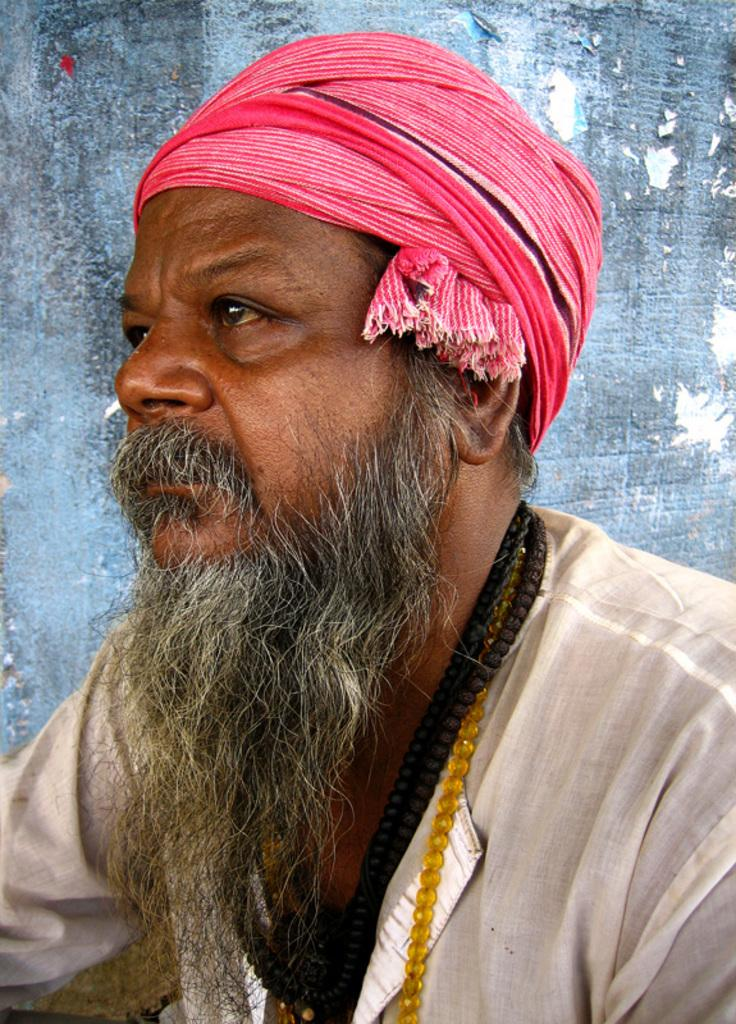Who or what is the main subject in the image? There is a person in the image. Can you describe the position of the person in the image? The person is in front. What can be seen behind the person in the image? There is a wall behind the person. What statement does the person make in the image? There is no statement visible in the image, as it only shows a person in front of a wall. 